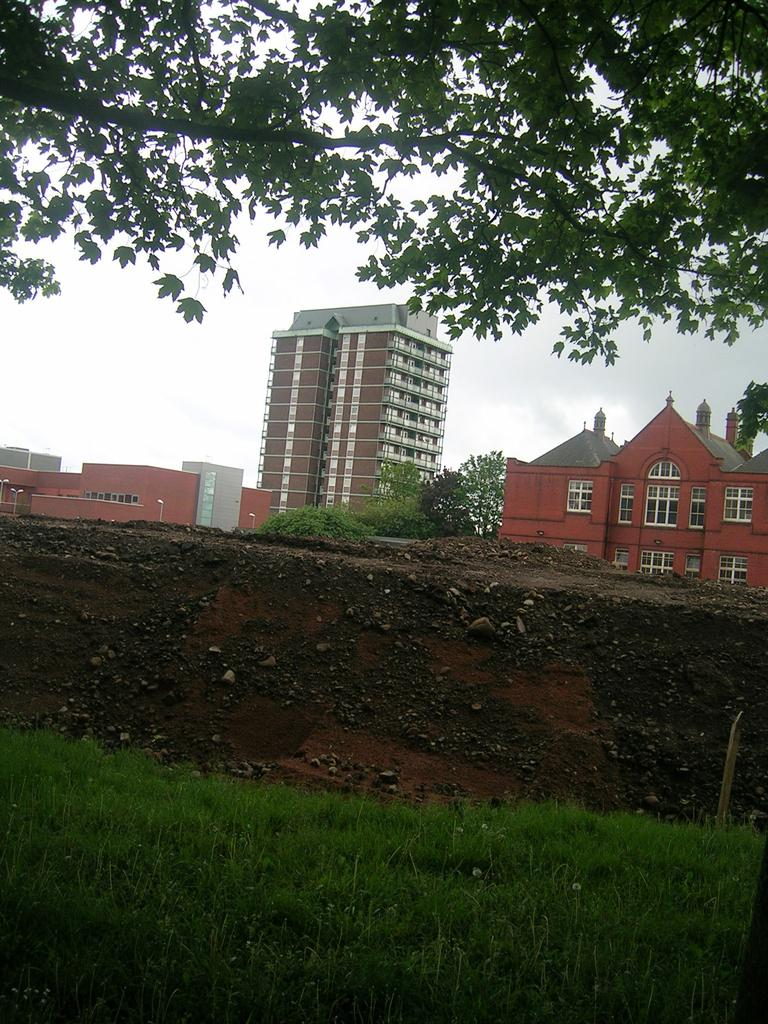What type of structures can be seen in the image? There are buildings in the image. What natural elements are present in the image? There are trees and grass in the image. What is the ground surface like in the image? The ground is visible in the image, and it appears to have stones present. What part of the natural environment is visible in the image? The sky is visible in the image. What is the profit margin of the account in the image? There is no account or profit margin mentioned in the image; it features buildings, trees, grass, stones, and the sky. 